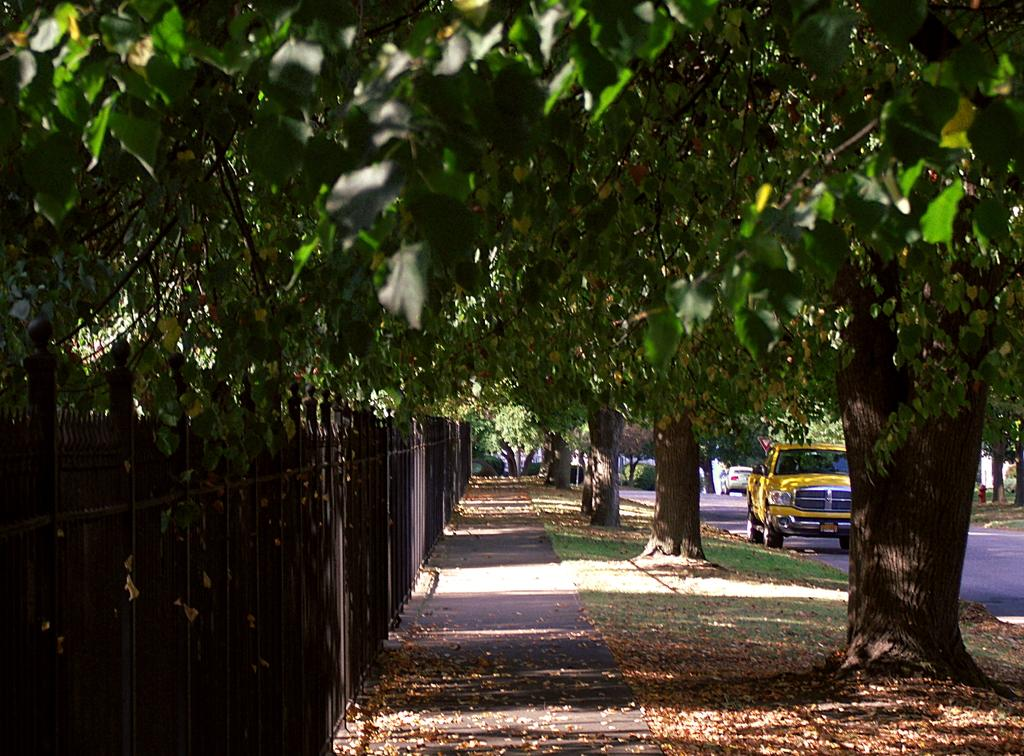What can be seen on the road in the image? There are vehicles on the road in the image. Where are the vehicles located in the image? The vehicles are on the right side of the image. What type of vegetation is present in the image? There are trees on the grassland in the image. What type of surface is visible in the image? There is a pavement in the image. What feature is associated with the pavement? The pavement has a fence. Can you tell me how many judges are sitting on the fence in the image? There are no judges present in the image; the pavement has a fence, but no judges are mentioned or visible. How many spiders are crawling on the trees in the image? There are no spiders mentioned or visible in the image; only trees are present. 